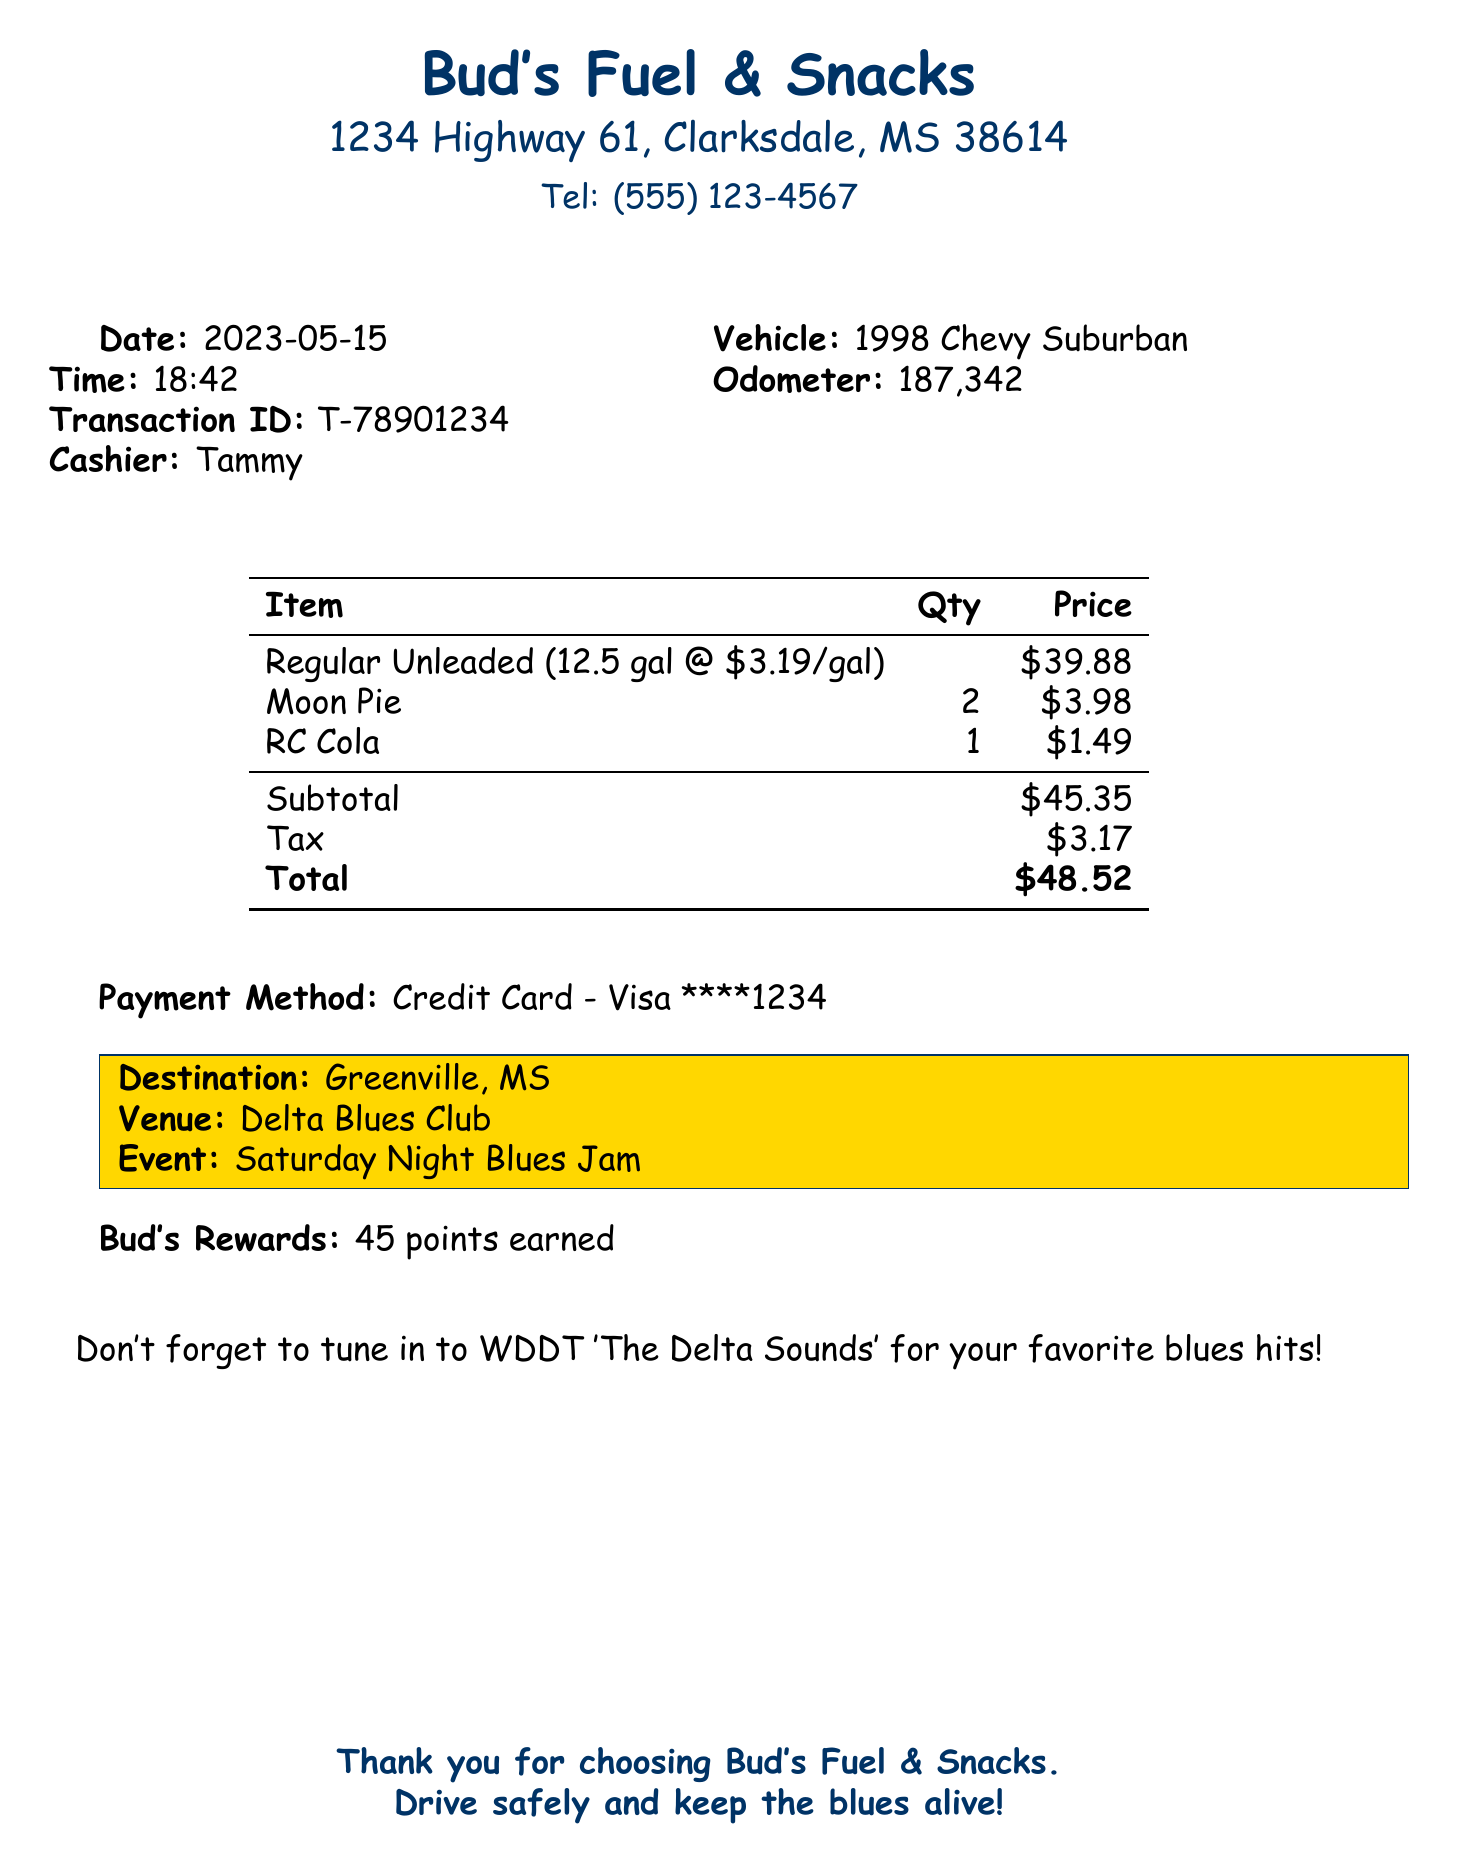What is the name of the gas station? The gas station's name is prominently displayed at the top of the receipt.
Answer: Bud's Fuel & Snacks What time was the transaction made? The time of the transaction is listed under the date on the receipt.
Answer: 18:42 What type of fuel was purchased? The type of fuel purchased is clearly stated on the receipt.
Answer: Regular Unleaded How many gallons of fuel were pumped? The number of gallons pumped is specified in the itemized fuel section.
Answer: 12.5 What is the total amount paid? The total amount is displayed clearly at the bottom of the receipt.
Answer: $48.52 What vehicle was used for the transaction? The vehicle associated with the transaction is mentioned in the document.
Answer: 1998 Chevy Suburban Where is the destination of the trip? The destination for the trip is highlighted on the receipt.
Answer: Greenville, MS Who was the cashier for this transaction? The cashier's name is noted on the receipt.
Answer: Tammy How many loyalty points were earned? The points earned from the loyalty program are stated towards the end of the document.
Answer: 45 